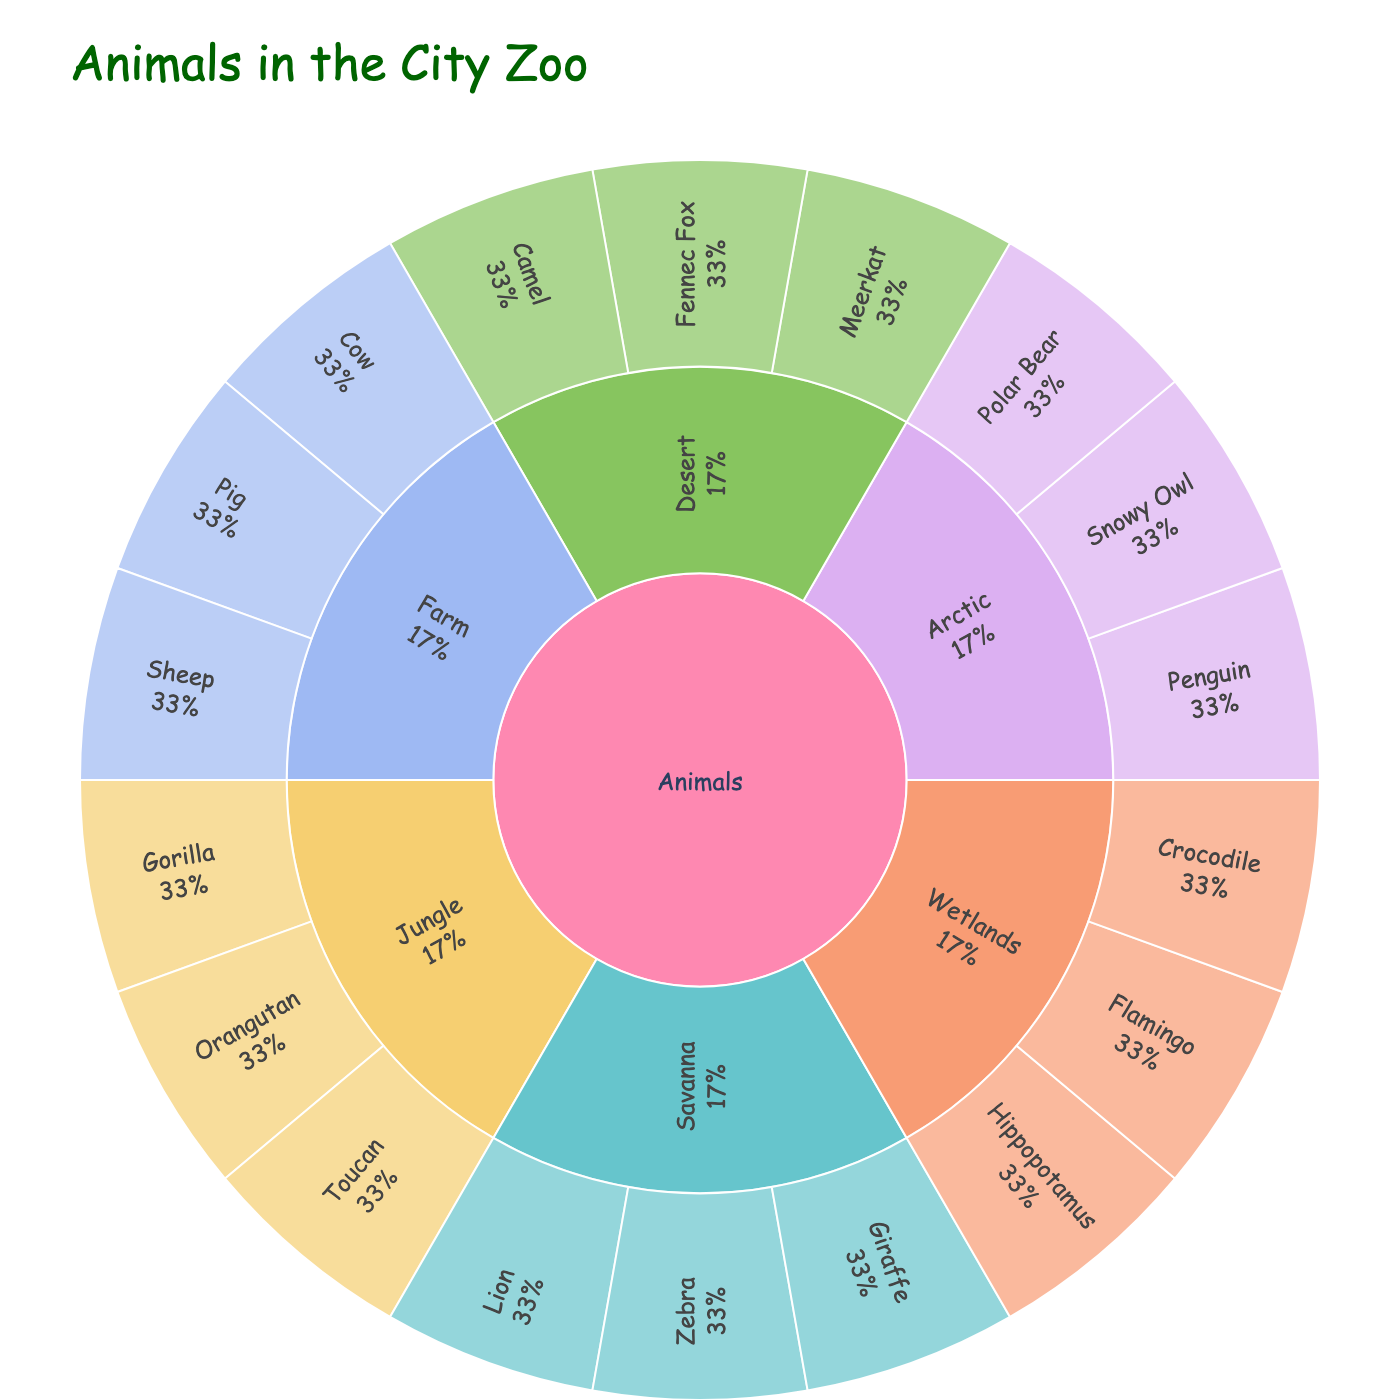What is the title of the figure? Look at the top of the figure and read the big text that describes what the plot is about.
Answer: Animals in the City Zoo How many species are shown in the Savanna habitat? Find the Savanna section on the plot and count the number of different species listed there.
Answer: 3 Which habitat has both a bird and a reptile species? Identify which habitat sections list both a bird and a reptile species. Birds are usually represented by species like flamingos and toucans, and reptiles by crocodiles.
Answer: Wetlands Are there more species in the Jungle or in the Desert? Count the number of species listed in the Jungle and in the Desert sections, then compare the counts.
Answer: Jungle What is the percentage of species in the Arctic habitat compared to the total number of species? Identify the Arctic section and count its species. Count the total number of all species in the plot. Calculate the percentage with (number in Arctic / total number) * 100.
Answer: 3 out of 18, or about 16.67% Which habitat has the fewest species? Look at all the habitat sections and find the one with the least number of species listed.
Answer: Farm List the species found in the Farm habitat. Locate the Farm section and list down all the species shown in that section.
Answer: Cow, Pig, Sheep Compare the number of species in Wetlands to Savanna. Which has more? Count the species in Wetlands and Savanna separately and compare the two numbers.
Answer: Both have 3 species each What color is used to represent the Desert habitat in this plot? Look at the plot's color scheme and identify the color used for the Desert section based on its label.
Answer: The color used is a pastel shade (specific color not determinable from data) What species is found in both the Savanna and the Jungle habitats? Locate species in both the Savanna and the Jungle sections and see if any species are listed in both habitats.
Answer: None 